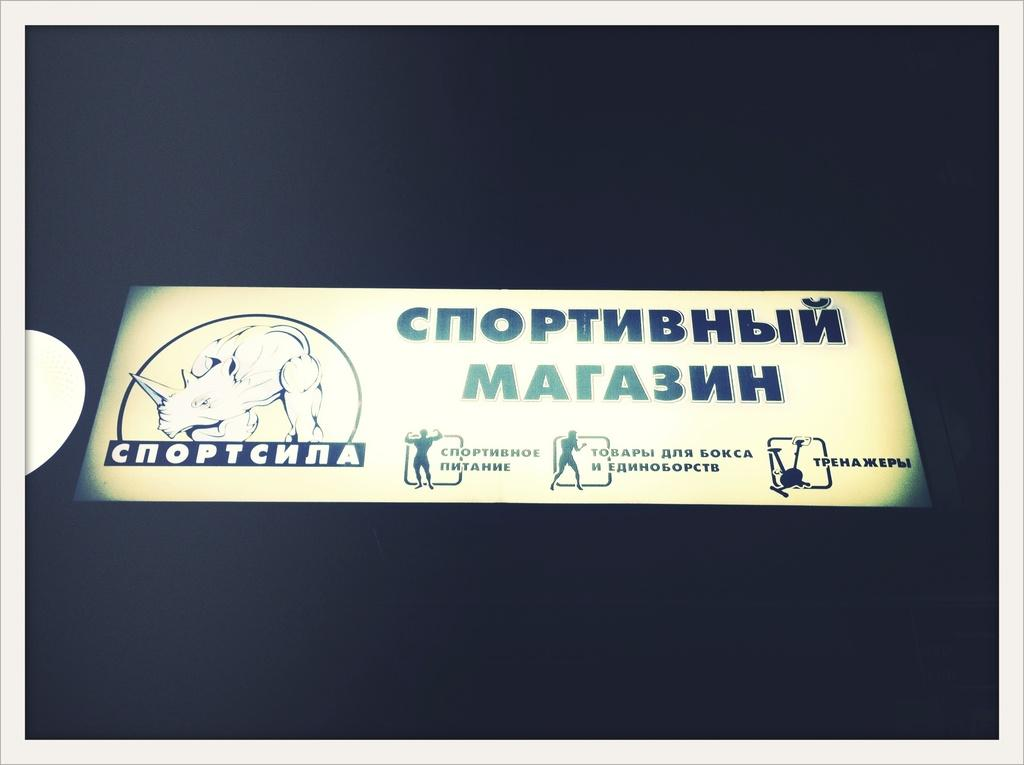What is the main subject in the center of the image? There is an advertisement board in the center of the image. What type of substance is being used for breakfast in the image? There is no reference to breakfast or any substances in the image, as it only features an advertisement board. 